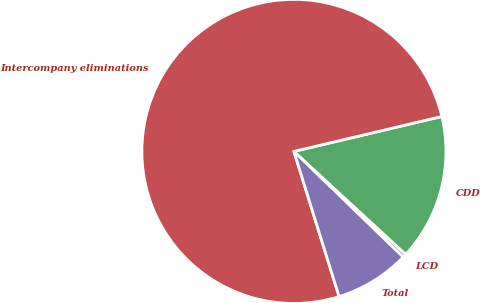Convert chart to OTSL. <chart><loc_0><loc_0><loc_500><loc_500><pie_chart><fcel>LCD<fcel>CDD<fcel>Intercompany eliminations<fcel>Total<nl><fcel>0.39%<fcel>15.54%<fcel>76.11%<fcel>7.96%<nl></chart> 